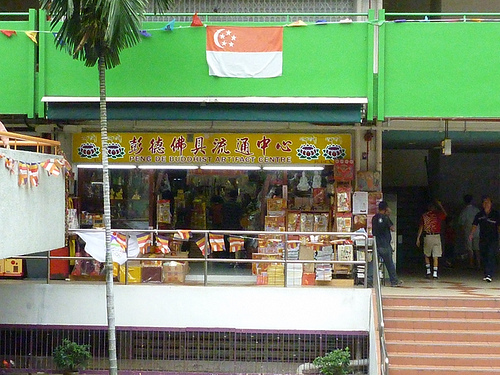<image>
Is there a flag on the store? Yes. Looking at the image, I can see the flag is positioned on top of the store, with the store providing support. 